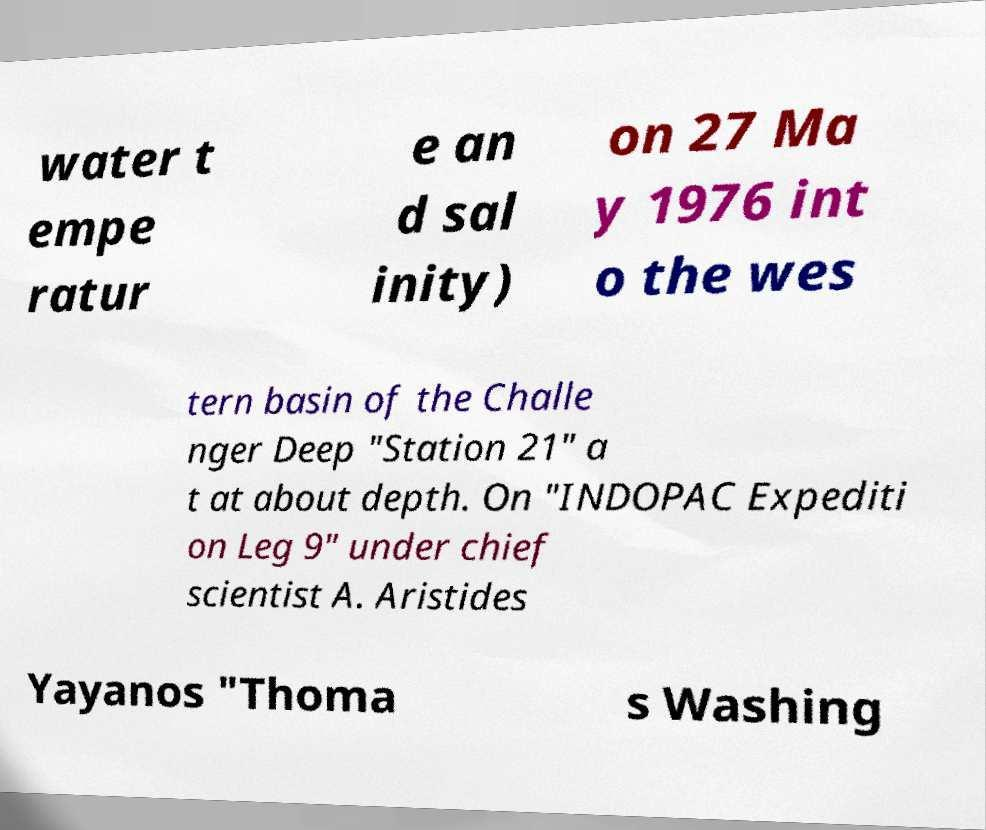I need the written content from this picture converted into text. Can you do that? water t empe ratur e an d sal inity) on 27 Ma y 1976 int o the wes tern basin of the Challe nger Deep "Station 21" a t at about depth. On "INDOPAC Expediti on Leg 9" under chief scientist A. Aristides Yayanos "Thoma s Washing 